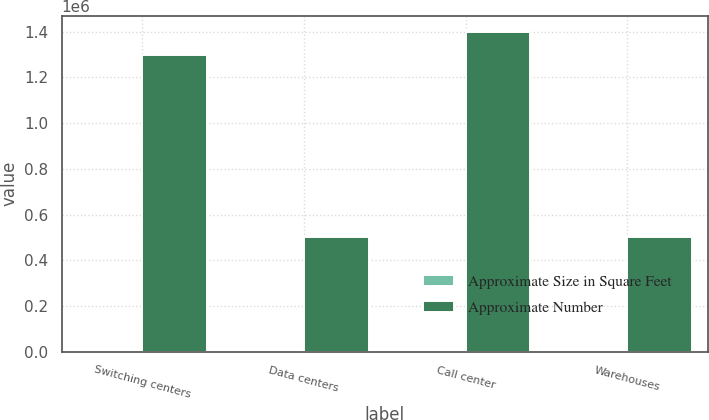Convert chart to OTSL. <chart><loc_0><loc_0><loc_500><loc_500><stacked_bar_chart><ecel><fcel>Switching centers<fcel>Data centers<fcel>Call center<fcel>Warehouses<nl><fcel>Approximate Size in Square Feet<fcel>61<fcel>6<fcel>17<fcel>15<nl><fcel>Approximate Number<fcel>1.3e+06<fcel>500000<fcel>1.4e+06<fcel>500000<nl></chart> 